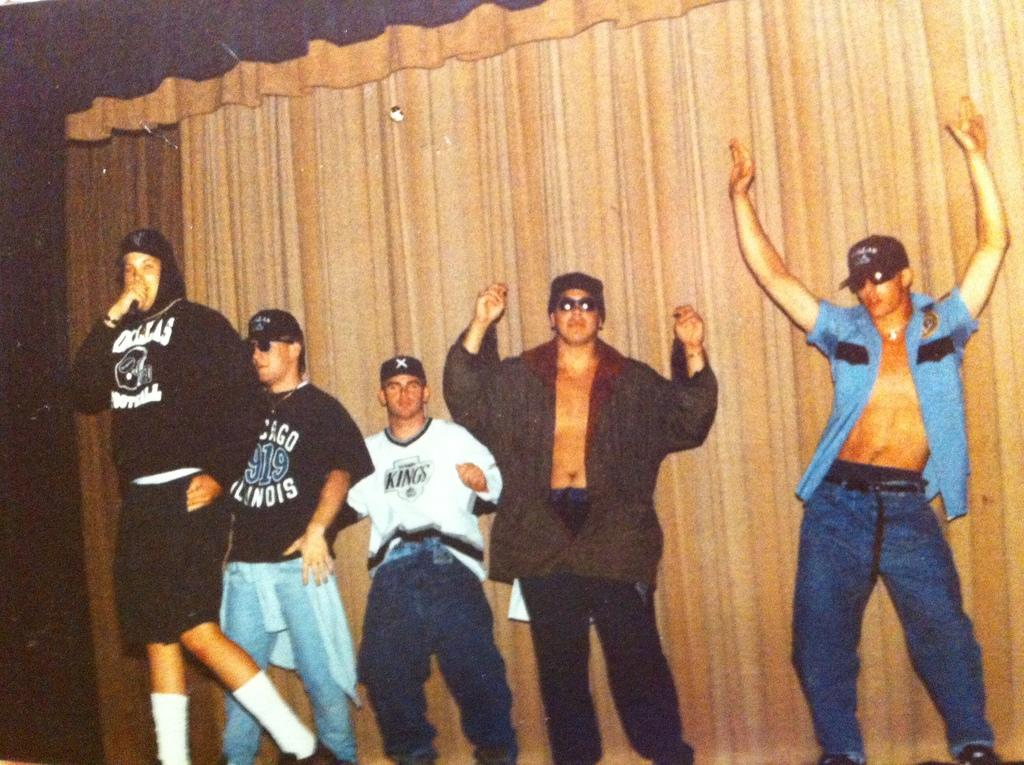<image>
Present a compact description of the photo's key features. Five men performing on stage, one wearing a Chicago sweatshirt. 